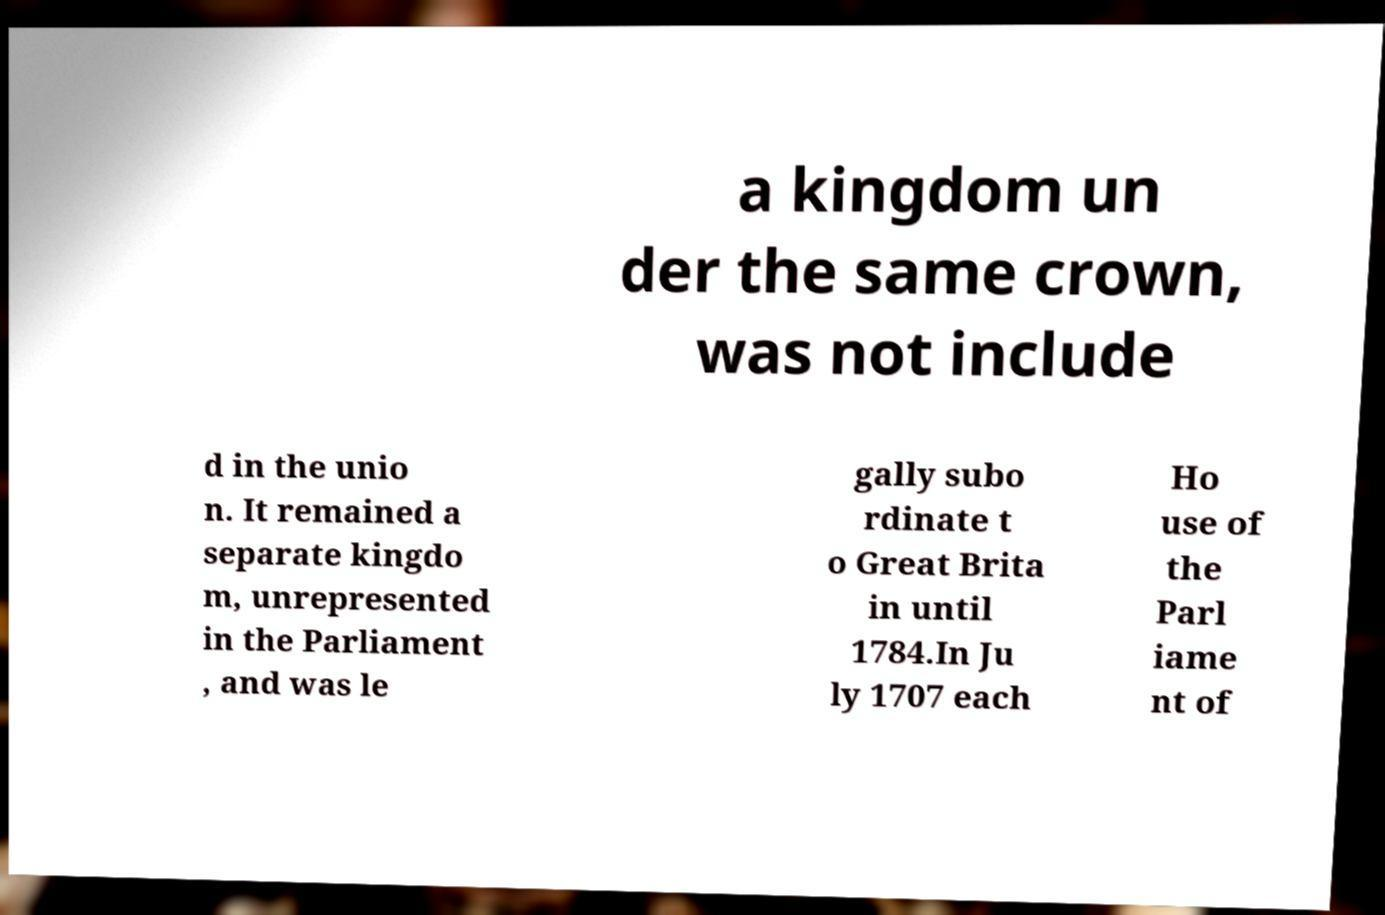Please read and relay the text visible in this image. What does it say? a kingdom un der the same crown, was not include d in the unio n. It remained a separate kingdo m, unrepresented in the Parliament , and was le gally subo rdinate t o Great Brita in until 1784.In Ju ly 1707 each Ho use of the Parl iame nt of 